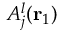<formula> <loc_0><loc_0><loc_500><loc_500>A _ { j } ^ { l } ( { r _ { 1 } } )</formula> 